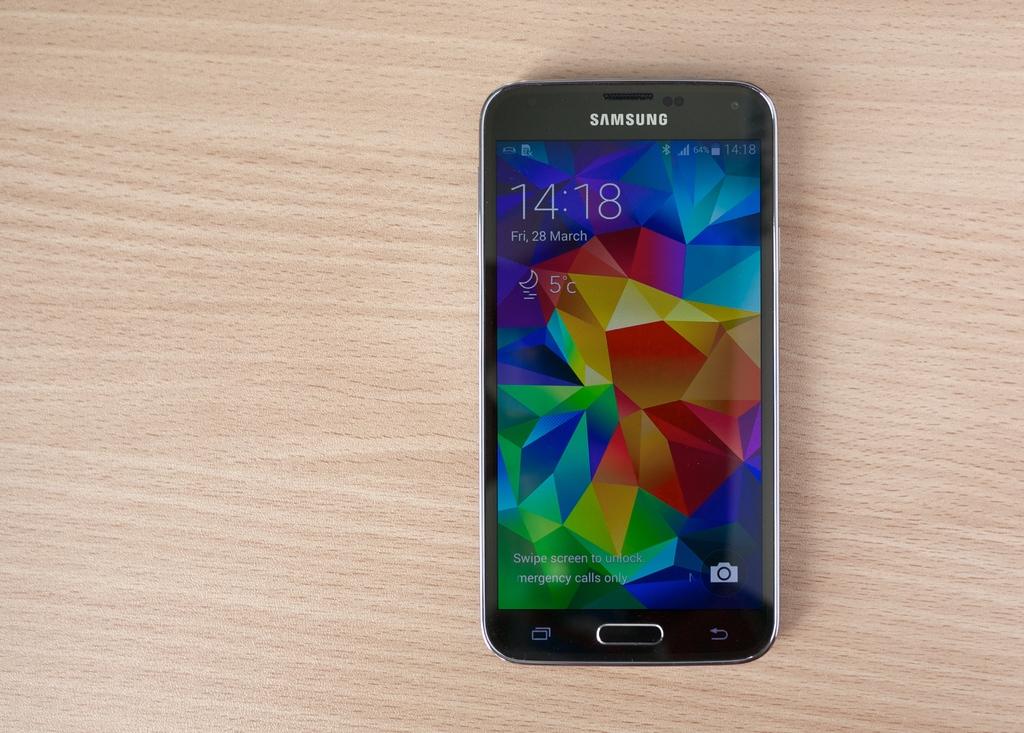What brand of phone is this?
Your answer should be compact. Samsung. What time does the phone read?
Provide a short and direct response. 14:18. 